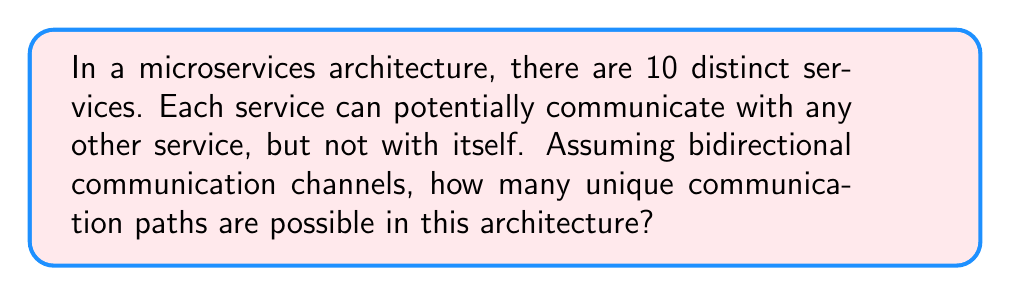Could you help me with this problem? Let's approach this step-by-step:

1) First, we need to understand what we're counting. We're looking for the number of unique communication paths between services, where each path represents a potential connection between two services.

2) This is a classic combinatorics problem. We're essentially choosing 2 services from 10, where the order doesn't matter (as the communication is bidirectional).

3) This scenario can be represented by the combination formula:

   $$\binom{n}{r} = \frac{n!}{r!(n-r)!}$$

   Where $n$ is the total number of services, and $r$ is the number of services we're selecting for each path.

4) In this case, $n = 10$ (total services) and $r = 2$ (we're selecting 2 services for each path).

5) Plugging these values into our formula:

   $$\binom{10}{2} = \frac{10!}{2!(10-2)!} = \frac{10!}{2!(8)!}$$

6) Expanding this:
   
   $$\frac{10 \times 9 \times 8!}{2 \times 1 \times 8!}$$

7) The 8! cancels out in the numerator and denominator:

   $$\frac{10 \times 9}{2 \times 1} = \frac{90}{2} = 45$$

Therefore, there are 45 unique communication paths possible in this microservices architecture.
Answer: 45 